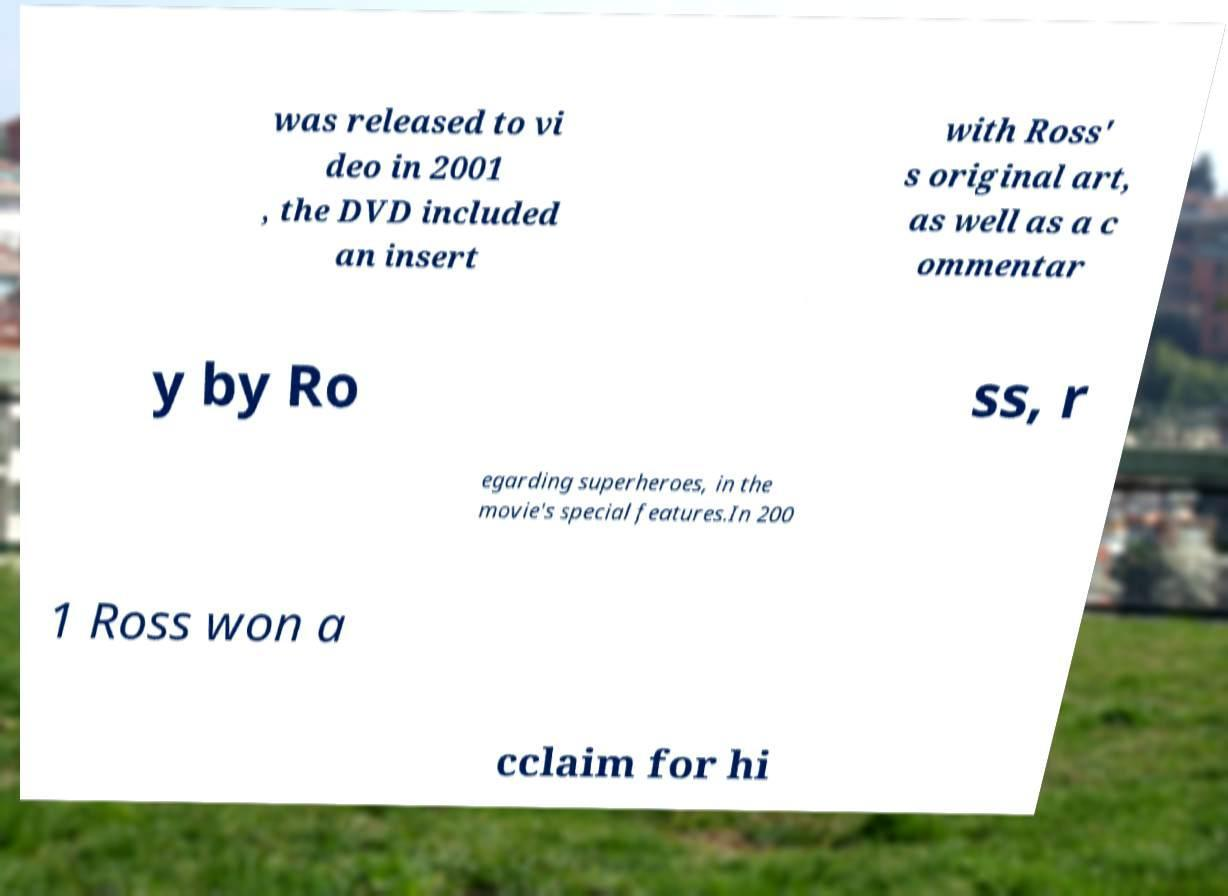Please identify and transcribe the text found in this image. was released to vi deo in 2001 , the DVD included an insert with Ross' s original art, as well as a c ommentar y by Ro ss, r egarding superheroes, in the movie's special features.In 200 1 Ross won a cclaim for hi 